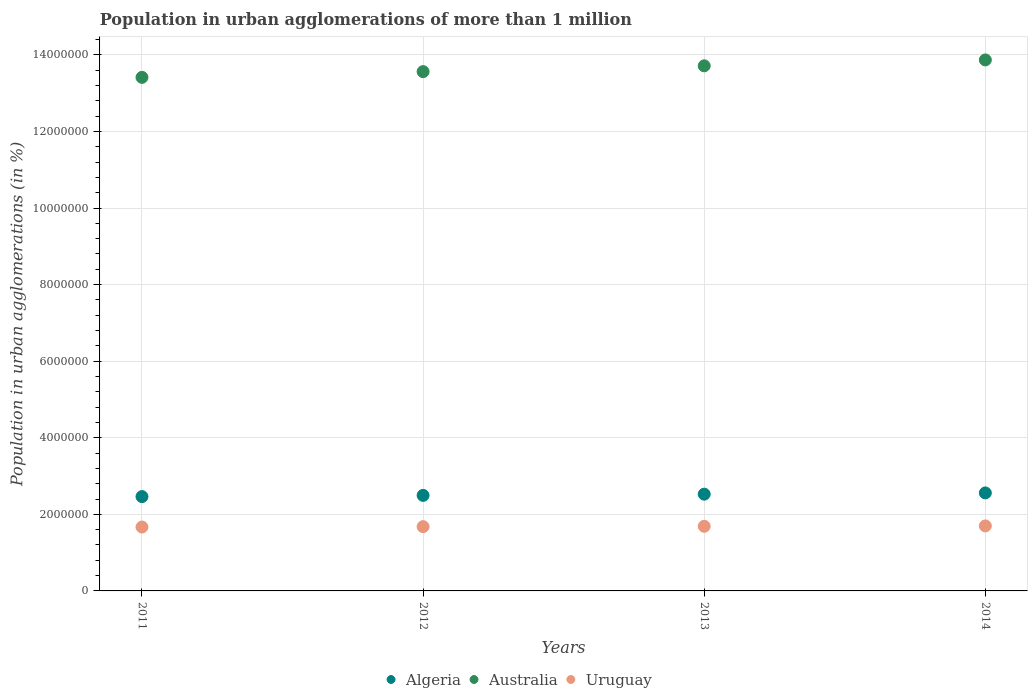How many different coloured dotlines are there?
Your response must be concise. 3. Is the number of dotlines equal to the number of legend labels?
Make the answer very short. Yes. What is the population in urban agglomerations in Uruguay in 2012?
Provide a succinct answer. 1.68e+06. Across all years, what is the maximum population in urban agglomerations in Australia?
Give a very brief answer. 1.39e+07. Across all years, what is the minimum population in urban agglomerations in Uruguay?
Offer a very short reply. 1.67e+06. In which year was the population in urban agglomerations in Australia maximum?
Keep it short and to the point. 2014. In which year was the population in urban agglomerations in Algeria minimum?
Provide a succinct answer. 2011. What is the total population in urban agglomerations in Australia in the graph?
Your answer should be very brief. 5.46e+07. What is the difference between the population in urban agglomerations in Uruguay in 2012 and that in 2013?
Keep it short and to the point. -9615. What is the difference between the population in urban agglomerations in Australia in 2014 and the population in urban agglomerations in Uruguay in 2012?
Your answer should be very brief. 1.22e+07. What is the average population in urban agglomerations in Australia per year?
Make the answer very short. 1.36e+07. In the year 2013, what is the difference between the population in urban agglomerations in Uruguay and population in urban agglomerations in Algeria?
Your answer should be compact. -8.39e+05. In how many years, is the population in urban agglomerations in Australia greater than 7200000 %?
Offer a terse response. 4. What is the ratio of the population in urban agglomerations in Australia in 2011 to that in 2013?
Your answer should be very brief. 0.98. Is the population in urban agglomerations in Algeria in 2013 less than that in 2014?
Keep it short and to the point. Yes. Is the difference between the population in urban agglomerations in Uruguay in 2012 and 2013 greater than the difference between the population in urban agglomerations in Algeria in 2012 and 2013?
Ensure brevity in your answer.  Yes. What is the difference between the highest and the second highest population in urban agglomerations in Algeria?
Offer a terse response. 3.25e+04. What is the difference between the highest and the lowest population in urban agglomerations in Australia?
Make the answer very short. 4.55e+05. Is the sum of the population in urban agglomerations in Australia in 2012 and 2013 greater than the maximum population in urban agglomerations in Algeria across all years?
Provide a short and direct response. Yes. Is it the case that in every year, the sum of the population in urban agglomerations in Australia and population in urban agglomerations in Uruguay  is greater than the population in urban agglomerations in Algeria?
Give a very brief answer. Yes. How many years are there in the graph?
Your answer should be very brief. 4. How are the legend labels stacked?
Ensure brevity in your answer.  Horizontal. What is the title of the graph?
Make the answer very short. Population in urban agglomerations of more than 1 million. What is the label or title of the Y-axis?
Provide a succinct answer. Population in urban agglomerations (in %). What is the Population in urban agglomerations (in %) in Algeria in 2011?
Offer a terse response. 2.46e+06. What is the Population in urban agglomerations (in %) of Australia in 2011?
Provide a succinct answer. 1.34e+07. What is the Population in urban agglomerations (in %) of Uruguay in 2011?
Your answer should be very brief. 1.67e+06. What is the Population in urban agglomerations (in %) of Algeria in 2012?
Your response must be concise. 2.49e+06. What is the Population in urban agglomerations (in %) in Australia in 2012?
Offer a very short reply. 1.36e+07. What is the Population in urban agglomerations (in %) of Uruguay in 2012?
Your response must be concise. 1.68e+06. What is the Population in urban agglomerations (in %) in Algeria in 2013?
Make the answer very short. 2.53e+06. What is the Population in urban agglomerations (in %) in Australia in 2013?
Your answer should be compact. 1.37e+07. What is the Population in urban agglomerations (in %) in Uruguay in 2013?
Keep it short and to the point. 1.69e+06. What is the Population in urban agglomerations (in %) of Algeria in 2014?
Your response must be concise. 2.56e+06. What is the Population in urban agglomerations (in %) of Australia in 2014?
Provide a short and direct response. 1.39e+07. What is the Population in urban agglomerations (in %) in Uruguay in 2014?
Your answer should be compact. 1.70e+06. Across all years, what is the maximum Population in urban agglomerations (in %) in Algeria?
Provide a succinct answer. 2.56e+06. Across all years, what is the maximum Population in urban agglomerations (in %) in Australia?
Your response must be concise. 1.39e+07. Across all years, what is the maximum Population in urban agglomerations (in %) of Uruguay?
Ensure brevity in your answer.  1.70e+06. Across all years, what is the minimum Population in urban agglomerations (in %) in Algeria?
Offer a terse response. 2.46e+06. Across all years, what is the minimum Population in urban agglomerations (in %) of Australia?
Your answer should be compact. 1.34e+07. Across all years, what is the minimum Population in urban agglomerations (in %) of Uruguay?
Keep it short and to the point. 1.67e+06. What is the total Population in urban agglomerations (in %) of Algeria in the graph?
Provide a succinct answer. 1.00e+07. What is the total Population in urban agglomerations (in %) in Australia in the graph?
Provide a short and direct response. 5.46e+07. What is the total Population in urban agglomerations (in %) of Uruguay in the graph?
Your response must be concise. 6.73e+06. What is the difference between the Population in urban agglomerations (in %) in Algeria in 2011 and that in 2012?
Make the answer very short. -3.16e+04. What is the difference between the Population in urban agglomerations (in %) in Australia in 2011 and that in 2012?
Your response must be concise. -1.50e+05. What is the difference between the Population in urban agglomerations (in %) in Uruguay in 2011 and that in 2012?
Offer a terse response. -9560. What is the difference between the Population in urban agglomerations (in %) of Algeria in 2011 and that in 2013?
Provide a short and direct response. -6.37e+04. What is the difference between the Population in urban agglomerations (in %) in Australia in 2011 and that in 2013?
Offer a terse response. -3.02e+05. What is the difference between the Population in urban agglomerations (in %) of Uruguay in 2011 and that in 2013?
Provide a succinct answer. -1.92e+04. What is the difference between the Population in urban agglomerations (in %) of Algeria in 2011 and that in 2014?
Provide a succinct answer. -9.62e+04. What is the difference between the Population in urban agglomerations (in %) in Australia in 2011 and that in 2014?
Provide a short and direct response. -4.55e+05. What is the difference between the Population in urban agglomerations (in %) of Uruguay in 2011 and that in 2014?
Make the answer very short. -2.88e+04. What is the difference between the Population in urban agglomerations (in %) of Algeria in 2012 and that in 2013?
Keep it short and to the point. -3.21e+04. What is the difference between the Population in urban agglomerations (in %) in Australia in 2012 and that in 2013?
Provide a short and direct response. -1.52e+05. What is the difference between the Population in urban agglomerations (in %) of Uruguay in 2012 and that in 2013?
Offer a very short reply. -9615. What is the difference between the Population in urban agglomerations (in %) in Algeria in 2012 and that in 2014?
Ensure brevity in your answer.  -6.45e+04. What is the difference between the Population in urban agglomerations (in %) of Australia in 2012 and that in 2014?
Your answer should be compact. -3.05e+05. What is the difference between the Population in urban agglomerations (in %) in Uruguay in 2012 and that in 2014?
Ensure brevity in your answer.  -1.93e+04. What is the difference between the Population in urban agglomerations (in %) in Algeria in 2013 and that in 2014?
Make the answer very short. -3.25e+04. What is the difference between the Population in urban agglomerations (in %) of Australia in 2013 and that in 2014?
Provide a short and direct response. -1.54e+05. What is the difference between the Population in urban agglomerations (in %) in Uruguay in 2013 and that in 2014?
Your answer should be very brief. -9670. What is the difference between the Population in urban agglomerations (in %) of Algeria in 2011 and the Population in urban agglomerations (in %) of Australia in 2012?
Your answer should be compact. -1.11e+07. What is the difference between the Population in urban agglomerations (in %) in Algeria in 2011 and the Population in urban agglomerations (in %) in Uruguay in 2012?
Ensure brevity in your answer.  7.85e+05. What is the difference between the Population in urban agglomerations (in %) of Australia in 2011 and the Population in urban agglomerations (in %) of Uruguay in 2012?
Your response must be concise. 1.17e+07. What is the difference between the Population in urban agglomerations (in %) of Algeria in 2011 and the Population in urban agglomerations (in %) of Australia in 2013?
Keep it short and to the point. -1.13e+07. What is the difference between the Population in urban agglomerations (in %) of Algeria in 2011 and the Population in urban agglomerations (in %) of Uruguay in 2013?
Offer a terse response. 7.75e+05. What is the difference between the Population in urban agglomerations (in %) of Australia in 2011 and the Population in urban agglomerations (in %) of Uruguay in 2013?
Provide a succinct answer. 1.17e+07. What is the difference between the Population in urban agglomerations (in %) in Algeria in 2011 and the Population in urban agglomerations (in %) in Australia in 2014?
Provide a short and direct response. -1.14e+07. What is the difference between the Population in urban agglomerations (in %) of Algeria in 2011 and the Population in urban agglomerations (in %) of Uruguay in 2014?
Provide a succinct answer. 7.66e+05. What is the difference between the Population in urban agglomerations (in %) in Australia in 2011 and the Population in urban agglomerations (in %) in Uruguay in 2014?
Make the answer very short. 1.17e+07. What is the difference between the Population in urban agglomerations (in %) in Algeria in 2012 and the Population in urban agglomerations (in %) in Australia in 2013?
Provide a succinct answer. -1.12e+07. What is the difference between the Population in urban agglomerations (in %) in Algeria in 2012 and the Population in urban agglomerations (in %) in Uruguay in 2013?
Offer a very short reply. 8.07e+05. What is the difference between the Population in urban agglomerations (in %) in Australia in 2012 and the Population in urban agglomerations (in %) in Uruguay in 2013?
Your answer should be very brief. 1.19e+07. What is the difference between the Population in urban agglomerations (in %) of Algeria in 2012 and the Population in urban agglomerations (in %) of Australia in 2014?
Your response must be concise. -1.14e+07. What is the difference between the Population in urban agglomerations (in %) in Algeria in 2012 and the Population in urban agglomerations (in %) in Uruguay in 2014?
Provide a short and direct response. 7.97e+05. What is the difference between the Population in urban agglomerations (in %) in Australia in 2012 and the Population in urban agglomerations (in %) in Uruguay in 2014?
Make the answer very short. 1.19e+07. What is the difference between the Population in urban agglomerations (in %) in Algeria in 2013 and the Population in urban agglomerations (in %) in Australia in 2014?
Keep it short and to the point. -1.13e+07. What is the difference between the Population in urban agglomerations (in %) of Algeria in 2013 and the Population in urban agglomerations (in %) of Uruguay in 2014?
Provide a short and direct response. 8.29e+05. What is the difference between the Population in urban agglomerations (in %) in Australia in 2013 and the Population in urban agglomerations (in %) in Uruguay in 2014?
Offer a very short reply. 1.20e+07. What is the average Population in urban agglomerations (in %) in Algeria per year?
Your answer should be compact. 2.51e+06. What is the average Population in urban agglomerations (in %) of Australia per year?
Ensure brevity in your answer.  1.36e+07. What is the average Population in urban agglomerations (in %) in Uruguay per year?
Offer a terse response. 1.68e+06. In the year 2011, what is the difference between the Population in urban agglomerations (in %) in Algeria and Population in urban agglomerations (in %) in Australia?
Offer a terse response. -1.09e+07. In the year 2011, what is the difference between the Population in urban agglomerations (in %) of Algeria and Population in urban agglomerations (in %) of Uruguay?
Your answer should be very brief. 7.94e+05. In the year 2011, what is the difference between the Population in urban agglomerations (in %) of Australia and Population in urban agglomerations (in %) of Uruguay?
Give a very brief answer. 1.17e+07. In the year 2012, what is the difference between the Population in urban agglomerations (in %) in Algeria and Population in urban agglomerations (in %) in Australia?
Your response must be concise. -1.11e+07. In the year 2012, what is the difference between the Population in urban agglomerations (in %) in Algeria and Population in urban agglomerations (in %) in Uruguay?
Your response must be concise. 8.16e+05. In the year 2012, what is the difference between the Population in urban agglomerations (in %) in Australia and Population in urban agglomerations (in %) in Uruguay?
Your answer should be very brief. 1.19e+07. In the year 2013, what is the difference between the Population in urban agglomerations (in %) in Algeria and Population in urban agglomerations (in %) in Australia?
Give a very brief answer. -1.12e+07. In the year 2013, what is the difference between the Population in urban agglomerations (in %) of Algeria and Population in urban agglomerations (in %) of Uruguay?
Provide a succinct answer. 8.39e+05. In the year 2013, what is the difference between the Population in urban agglomerations (in %) of Australia and Population in urban agglomerations (in %) of Uruguay?
Provide a short and direct response. 1.20e+07. In the year 2014, what is the difference between the Population in urban agglomerations (in %) in Algeria and Population in urban agglomerations (in %) in Australia?
Make the answer very short. -1.13e+07. In the year 2014, what is the difference between the Population in urban agglomerations (in %) in Algeria and Population in urban agglomerations (in %) in Uruguay?
Ensure brevity in your answer.  8.62e+05. In the year 2014, what is the difference between the Population in urban agglomerations (in %) in Australia and Population in urban agglomerations (in %) in Uruguay?
Your answer should be very brief. 1.22e+07. What is the ratio of the Population in urban agglomerations (in %) in Algeria in 2011 to that in 2012?
Offer a very short reply. 0.99. What is the ratio of the Population in urban agglomerations (in %) of Uruguay in 2011 to that in 2012?
Offer a terse response. 0.99. What is the ratio of the Population in urban agglomerations (in %) of Algeria in 2011 to that in 2013?
Ensure brevity in your answer.  0.97. What is the ratio of the Population in urban agglomerations (in %) in Uruguay in 2011 to that in 2013?
Your response must be concise. 0.99. What is the ratio of the Population in urban agglomerations (in %) of Algeria in 2011 to that in 2014?
Offer a terse response. 0.96. What is the ratio of the Population in urban agglomerations (in %) of Australia in 2011 to that in 2014?
Offer a terse response. 0.97. What is the ratio of the Population in urban agglomerations (in %) of Uruguay in 2011 to that in 2014?
Offer a very short reply. 0.98. What is the ratio of the Population in urban agglomerations (in %) in Algeria in 2012 to that in 2013?
Give a very brief answer. 0.99. What is the ratio of the Population in urban agglomerations (in %) in Australia in 2012 to that in 2013?
Keep it short and to the point. 0.99. What is the ratio of the Population in urban agglomerations (in %) in Uruguay in 2012 to that in 2013?
Your response must be concise. 0.99. What is the ratio of the Population in urban agglomerations (in %) in Algeria in 2012 to that in 2014?
Offer a very short reply. 0.97. What is the ratio of the Population in urban agglomerations (in %) of Algeria in 2013 to that in 2014?
Your answer should be very brief. 0.99. What is the ratio of the Population in urban agglomerations (in %) in Australia in 2013 to that in 2014?
Provide a short and direct response. 0.99. What is the difference between the highest and the second highest Population in urban agglomerations (in %) in Algeria?
Give a very brief answer. 3.25e+04. What is the difference between the highest and the second highest Population in urban agglomerations (in %) of Australia?
Your answer should be very brief. 1.54e+05. What is the difference between the highest and the second highest Population in urban agglomerations (in %) in Uruguay?
Make the answer very short. 9670. What is the difference between the highest and the lowest Population in urban agglomerations (in %) in Algeria?
Your answer should be compact. 9.62e+04. What is the difference between the highest and the lowest Population in urban agglomerations (in %) of Australia?
Your response must be concise. 4.55e+05. What is the difference between the highest and the lowest Population in urban agglomerations (in %) of Uruguay?
Provide a succinct answer. 2.88e+04. 